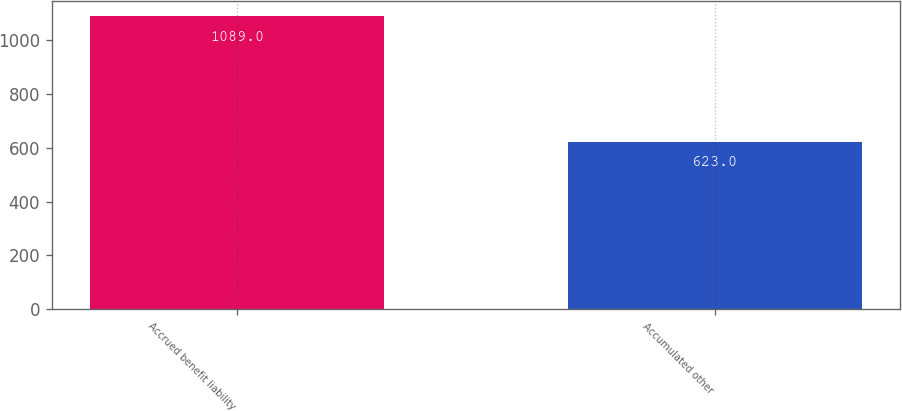<chart> <loc_0><loc_0><loc_500><loc_500><bar_chart><fcel>Accrued benefit liability<fcel>Accumulated other<nl><fcel>1089<fcel>623<nl></chart> 